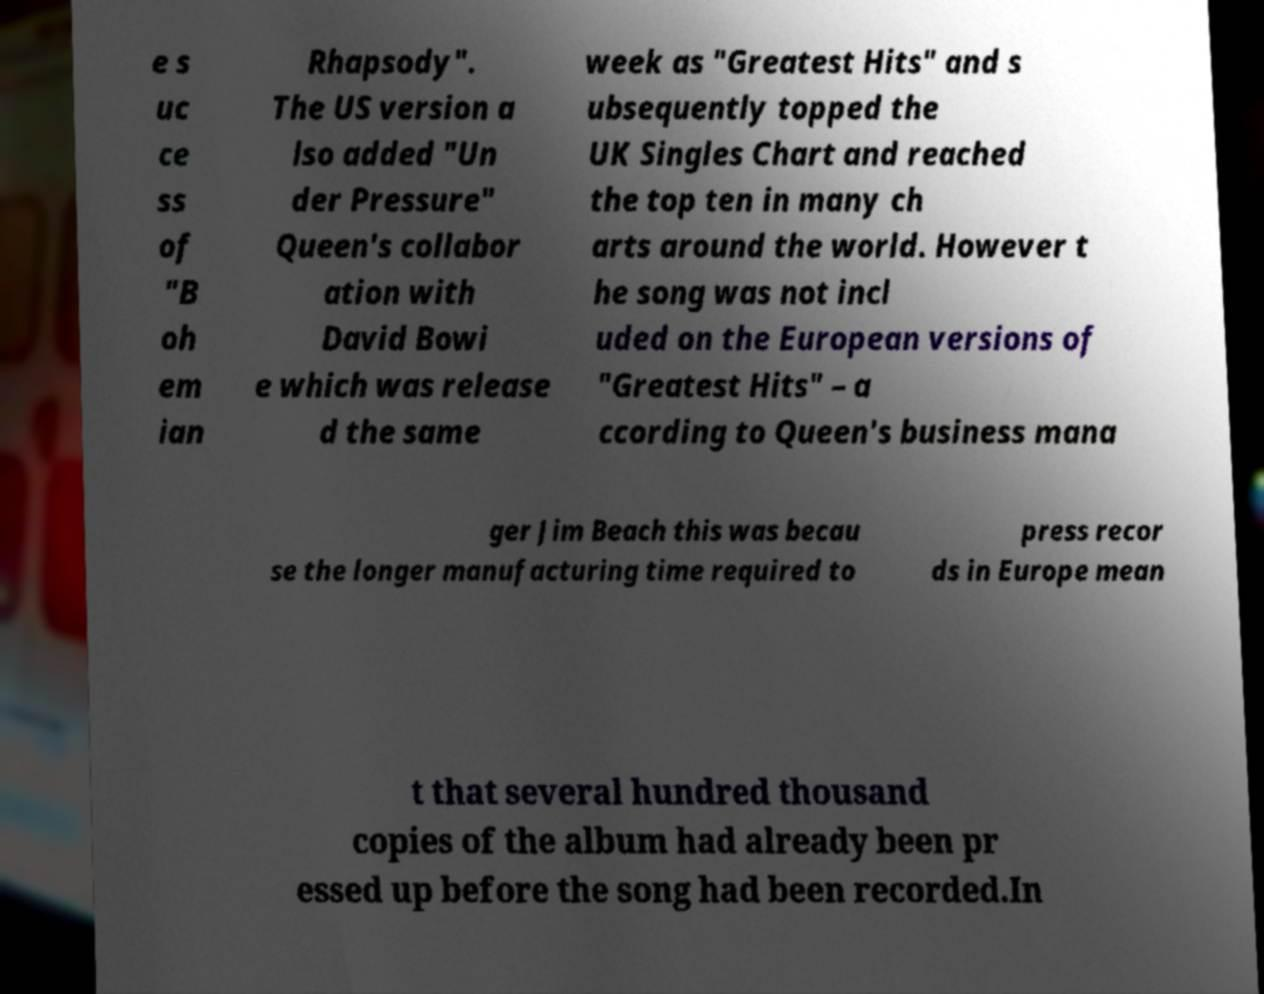Could you extract and type out the text from this image? e s uc ce ss of "B oh em ian Rhapsody". The US version a lso added "Un der Pressure" Queen's collabor ation with David Bowi e which was release d the same week as "Greatest Hits" and s ubsequently topped the UK Singles Chart and reached the top ten in many ch arts around the world. However t he song was not incl uded on the European versions of "Greatest Hits" – a ccording to Queen's business mana ger Jim Beach this was becau se the longer manufacturing time required to press recor ds in Europe mean t that several hundred thousand copies of the album had already been pr essed up before the song had been recorded.In 